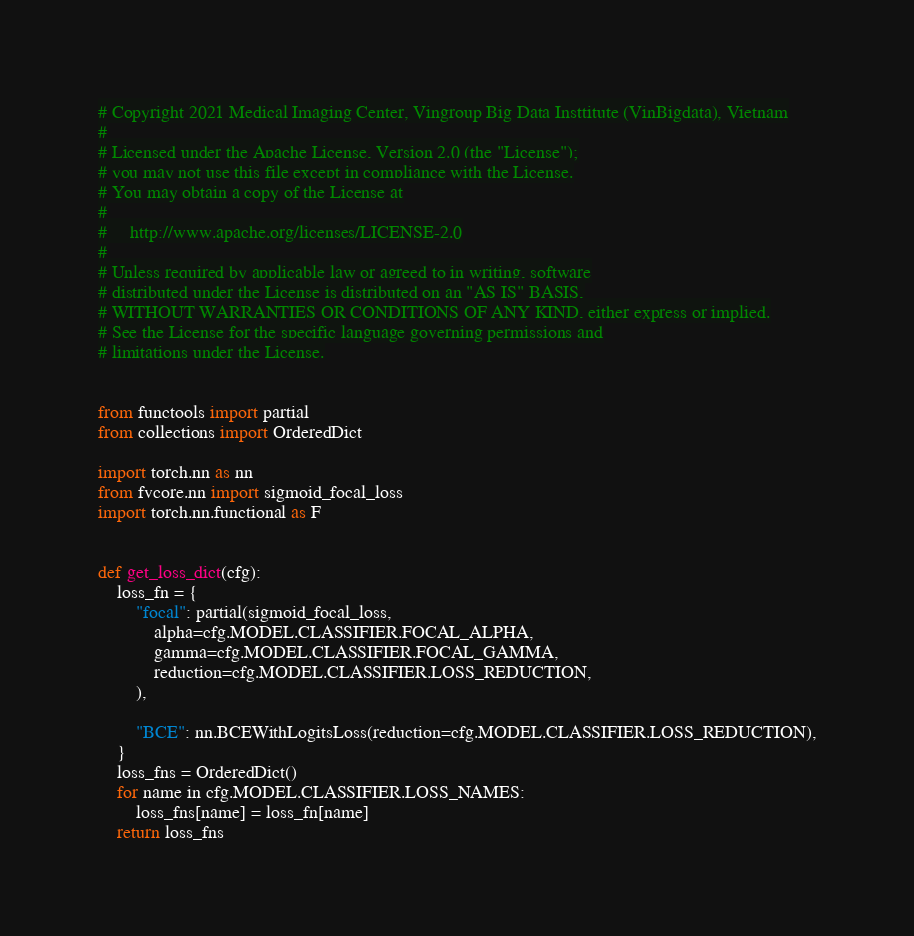<code> <loc_0><loc_0><loc_500><loc_500><_Python_># Copyright 2021 Medical Imaging Center, Vingroup Big Data Insttitute (VinBigdata), Vietnam
#
# Licensed under the Apache License, Version 2.0 (the "License");
# you may not use this file except in compliance with the License.
# You may obtain a copy of the License at
#
#     http://www.apache.org/licenses/LICENSE-2.0
#
# Unless required by applicable law or agreed to in writing, software
# distributed under the License is distributed on an "AS IS" BASIS,
# WITHOUT WARRANTIES OR CONDITIONS OF ANY KIND, either express or implied.
# See the License for the specific language governing permissions and
# limitations under the License.


from functools import partial 
from collections import OrderedDict

import torch.nn as nn
from fvcore.nn import sigmoid_focal_loss
import torch.nn.functional as F


def get_loss_dict(cfg):
    loss_fn = {
        "focal": partial(sigmoid_focal_loss, 
            alpha=cfg.MODEL.CLASSIFIER.FOCAL_ALPHA,
            gamma=cfg.MODEL.CLASSIFIER.FOCAL_GAMMA,
            reduction=cfg.MODEL.CLASSIFIER.LOSS_REDUCTION,
        ),

        "BCE": nn.BCEWithLogitsLoss(reduction=cfg.MODEL.CLASSIFIER.LOSS_REDUCTION),
    }
    loss_fns = OrderedDict()
    for name in cfg.MODEL.CLASSIFIER.LOSS_NAMES:
        loss_fns[name] = loss_fn[name]
    return loss_fns</code> 